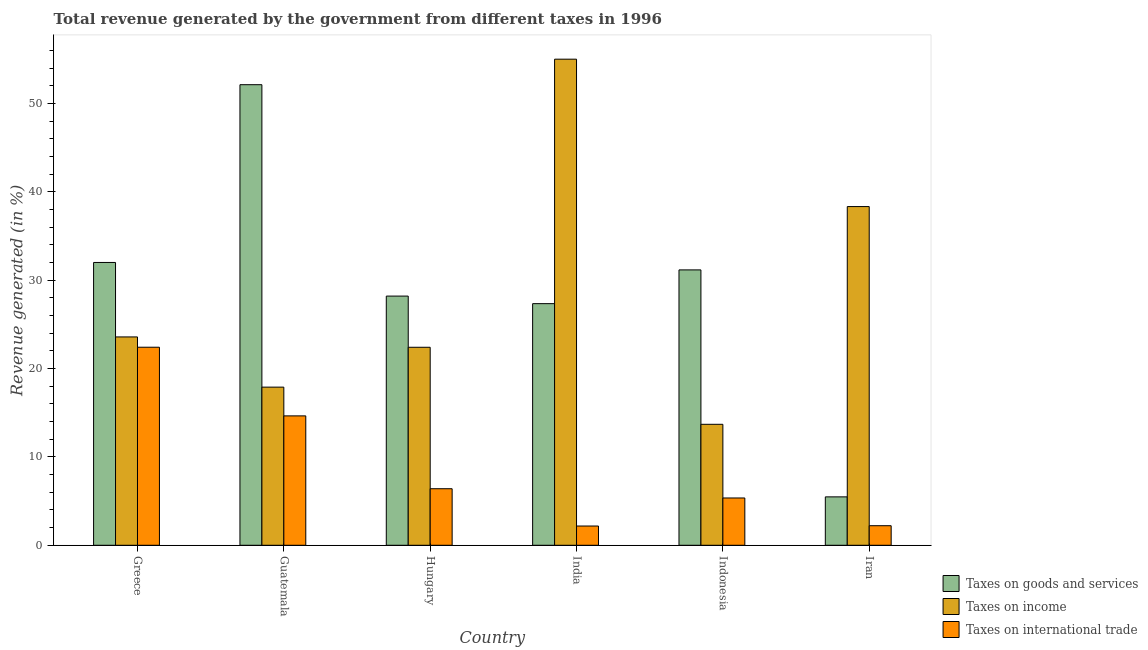How many groups of bars are there?
Your response must be concise. 6. What is the label of the 1st group of bars from the left?
Make the answer very short. Greece. In how many cases, is the number of bars for a given country not equal to the number of legend labels?
Offer a terse response. 0. What is the percentage of revenue generated by taxes on goods and services in Indonesia?
Keep it short and to the point. 31.16. Across all countries, what is the maximum percentage of revenue generated by taxes on income?
Offer a terse response. 55.01. Across all countries, what is the minimum percentage of revenue generated by taxes on goods and services?
Offer a very short reply. 5.48. In which country was the percentage of revenue generated by tax on international trade minimum?
Provide a short and direct response. India. What is the total percentage of revenue generated by taxes on goods and services in the graph?
Your answer should be compact. 176.3. What is the difference between the percentage of revenue generated by taxes on goods and services in Guatemala and that in Indonesia?
Keep it short and to the point. 20.96. What is the difference between the percentage of revenue generated by tax on international trade in Iran and the percentage of revenue generated by taxes on goods and services in India?
Make the answer very short. -25.13. What is the average percentage of revenue generated by tax on international trade per country?
Your answer should be very brief. 8.87. What is the difference between the percentage of revenue generated by tax on international trade and percentage of revenue generated by taxes on goods and services in Hungary?
Your response must be concise. -21.8. In how many countries, is the percentage of revenue generated by tax on international trade greater than 10 %?
Make the answer very short. 2. What is the ratio of the percentage of revenue generated by taxes on income in Guatemala to that in Hungary?
Provide a short and direct response. 0.8. Is the percentage of revenue generated by taxes on goods and services in Greece less than that in Iran?
Provide a succinct answer. No. What is the difference between the highest and the second highest percentage of revenue generated by taxes on goods and services?
Provide a short and direct response. 20.12. What is the difference between the highest and the lowest percentage of revenue generated by taxes on income?
Ensure brevity in your answer.  41.32. In how many countries, is the percentage of revenue generated by taxes on income greater than the average percentage of revenue generated by taxes on income taken over all countries?
Keep it short and to the point. 2. Is the sum of the percentage of revenue generated by taxes on goods and services in Guatemala and India greater than the maximum percentage of revenue generated by tax on international trade across all countries?
Keep it short and to the point. Yes. What does the 3rd bar from the left in Iran represents?
Keep it short and to the point. Taxes on international trade. What does the 2nd bar from the right in India represents?
Your answer should be very brief. Taxes on income. Is it the case that in every country, the sum of the percentage of revenue generated by taxes on goods and services and percentage of revenue generated by taxes on income is greater than the percentage of revenue generated by tax on international trade?
Give a very brief answer. Yes. How many bars are there?
Your response must be concise. 18. How many countries are there in the graph?
Offer a very short reply. 6. Are the values on the major ticks of Y-axis written in scientific E-notation?
Provide a succinct answer. No. Where does the legend appear in the graph?
Offer a terse response. Bottom right. What is the title of the graph?
Your response must be concise. Total revenue generated by the government from different taxes in 1996. Does "Unemployment benefits" appear as one of the legend labels in the graph?
Offer a very short reply. No. What is the label or title of the Y-axis?
Make the answer very short. Revenue generated (in %). What is the Revenue generated (in %) of Taxes on goods and services in Greece?
Provide a short and direct response. 32. What is the Revenue generated (in %) of Taxes on income in Greece?
Provide a succinct answer. 23.58. What is the Revenue generated (in %) in Taxes on international trade in Greece?
Make the answer very short. 22.41. What is the Revenue generated (in %) in Taxes on goods and services in Guatemala?
Make the answer very short. 52.12. What is the Revenue generated (in %) in Taxes on income in Guatemala?
Offer a terse response. 17.89. What is the Revenue generated (in %) in Taxes on international trade in Guatemala?
Ensure brevity in your answer.  14.64. What is the Revenue generated (in %) of Taxes on goods and services in Hungary?
Ensure brevity in your answer.  28.2. What is the Revenue generated (in %) in Taxes on income in Hungary?
Your answer should be very brief. 22.41. What is the Revenue generated (in %) of Taxes on international trade in Hungary?
Ensure brevity in your answer.  6.4. What is the Revenue generated (in %) in Taxes on goods and services in India?
Offer a very short reply. 27.34. What is the Revenue generated (in %) in Taxes on income in India?
Give a very brief answer. 55.01. What is the Revenue generated (in %) in Taxes on international trade in India?
Make the answer very short. 2.18. What is the Revenue generated (in %) of Taxes on goods and services in Indonesia?
Give a very brief answer. 31.16. What is the Revenue generated (in %) of Taxes on income in Indonesia?
Provide a short and direct response. 13.69. What is the Revenue generated (in %) in Taxes on international trade in Indonesia?
Ensure brevity in your answer.  5.35. What is the Revenue generated (in %) in Taxes on goods and services in Iran?
Provide a succinct answer. 5.48. What is the Revenue generated (in %) of Taxes on income in Iran?
Your response must be concise. 38.33. What is the Revenue generated (in %) in Taxes on international trade in Iran?
Offer a terse response. 2.21. Across all countries, what is the maximum Revenue generated (in %) of Taxes on goods and services?
Your answer should be very brief. 52.12. Across all countries, what is the maximum Revenue generated (in %) of Taxes on income?
Your response must be concise. 55.01. Across all countries, what is the maximum Revenue generated (in %) of Taxes on international trade?
Your answer should be compact. 22.41. Across all countries, what is the minimum Revenue generated (in %) of Taxes on goods and services?
Give a very brief answer. 5.48. Across all countries, what is the minimum Revenue generated (in %) of Taxes on income?
Keep it short and to the point. 13.69. Across all countries, what is the minimum Revenue generated (in %) in Taxes on international trade?
Offer a very short reply. 2.18. What is the total Revenue generated (in %) in Taxes on goods and services in the graph?
Your response must be concise. 176.3. What is the total Revenue generated (in %) of Taxes on income in the graph?
Give a very brief answer. 170.9. What is the total Revenue generated (in %) of Taxes on international trade in the graph?
Your response must be concise. 53.2. What is the difference between the Revenue generated (in %) in Taxes on goods and services in Greece and that in Guatemala?
Your response must be concise. -20.12. What is the difference between the Revenue generated (in %) in Taxes on income in Greece and that in Guatemala?
Make the answer very short. 5.68. What is the difference between the Revenue generated (in %) of Taxes on international trade in Greece and that in Guatemala?
Offer a very short reply. 7.77. What is the difference between the Revenue generated (in %) of Taxes on goods and services in Greece and that in Hungary?
Your answer should be compact. 3.81. What is the difference between the Revenue generated (in %) of Taxes on income in Greece and that in Hungary?
Keep it short and to the point. 1.17. What is the difference between the Revenue generated (in %) in Taxes on international trade in Greece and that in Hungary?
Provide a succinct answer. 16.01. What is the difference between the Revenue generated (in %) in Taxes on goods and services in Greece and that in India?
Provide a short and direct response. 4.66. What is the difference between the Revenue generated (in %) of Taxes on income in Greece and that in India?
Provide a succinct answer. -31.43. What is the difference between the Revenue generated (in %) in Taxes on international trade in Greece and that in India?
Provide a short and direct response. 20.23. What is the difference between the Revenue generated (in %) of Taxes on goods and services in Greece and that in Indonesia?
Your response must be concise. 0.84. What is the difference between the Revenue generated (in %) in Taxes on income in Greece and that in Indonesia?
Offer a terse response. 9.89. What is the difference between the Revenue generated (in %) in Taxes on international trade in Greece and that in Indonesia?
Offer a terse response. 17.06. What is the difference between the Revenue generated (in %) of Taxes on goods and services in Greece and that in Iran?
Keep it short and to the point. 26.53. What is the difference between the Revenue generated (in %) of Taxes on income in Greece and that in Iran?
Your response must be concise. -14.75. What is the difference between the Revenue generated (in %) in Taxes on international trade in Greece and that in Iran?
Make the answer very short. 20.2. What is the difference between the Revenue generated (in %) of Taxes on goods and services in Guatemala and that in Hungary?
Keep it short and to the point. 23.92. What is the difference between the Revenue generated (in %) in Taxes on income in Guatemala and that in Hungary?
Offer a terse response. -4.51. What is the difference between the Revenue generated (in %) of Taxes on international trade in Guatemala and that in Hungary?
Keep it short and to the point. 8.24. What is the difference between the Revenue generated (in %) of Taxes on goods and services in Guatemala and that in India?
Provide a short and direct response. 24.78. What is the difference between the Revenue generated (in %) of Taxes on income in Guatemala and that in India?
Offer a terse response. -37.11. What is the difference between the Revenue generated (in %) in Taxes on international trade in Guatemala and that in India?
Keep it short and to the point. 12.46. What is the difference between the Revenue generated (in %) in Taxes on goods and services in Guatemala and that in Indonesia?
Offer a very short reply. 20.96. What is the difference between the Revenue generated (in %) of Taxes on income in Guatemala and that in Indonesia?
Offer a very short reply. 4.21. What is the difference between the Revenue generated (in %) of Taxes on international trade in Guatemala and that in Indonesia?
Ensure brevity in your answer.  9.29. What is the difference between the Revenue generated (in %) of Taxes on goods and services in Guatemala and that in Iran?
Provide a succinct answer. 46.64. What is the difference between the Revenue generated (in %) of Taxes on income in Guatemala and that in Iran?
Provide a succinct answer. -20.43. What is the difference between the Revenue generated (in %) in Taxes on international trade in Guatemala and that in Iran?
Your response must be concise. 12.43. What is the difference between the Revenue generated (in %) of Taxes on goods and services in Hungary and that in India?
Provide a short and direct response. 0.86. What is the difference between the Revenue generated (in %) of Taxes on income in Hungary and that in India?
Give a very brief answer. -32.6. What is the difference between the Revenue generated (in %) in Taxes on international trade in Hungary and that in India?
Offer a terse response. 4.22. What is the difference between the Revenue generated (in %) of Taxes on goods and services in Hungary and that in Indonesia?
Your answer should be compact. -2.96. What is the difference between the Revenue generated (in %) in Taxes on income in Hungary and that in Indonesia?
Provide a succinct answer. 8.72. What is the difference between the Revenue generated (in %) in Taxes on international trade in Hungary and that in Indonesia?
Give a very brief answer. 1.05. What is the difference between the Revenue generated (in %) of Taxes on goods and services in Hungary and that in Iran?
Ensure brevity in your answer.  22.72. What is the difference between the Revenue generated (in %) in Taxes on income in Hungary and that in Iran?
Ensure brevity in your answer.  -15.92. What is the difference between the Revenue generated (in %) of Taxes on international trade in Hungary and that in Iran?
Your response must be concise. 4.18. What is the difference between the Revenue generated (in %) of Taxes on goods and services in India and that in Indonesia?
Offer a terse response. -3.82. What is the difference between the Revenue generated (in %) in Taxes on income in India and that in Indonesia?
Make the answer very short. 41.32. What is the difference between the Revenue generated (in %) of Taxes on international trade in India and that in Indonesia?
Give a very brief answer. -3.17. What is the difference between the Revenue generated (in %) of Taxes on goods and services in India and that in Iran?
Your response must be concise. 21.86. What is the difference between the Revenue generated (in %) in Taxes on income in India and that in Iran?
Provide a succinct answer. 16.68. What is the difference between the Revenue generated (in %) of Taxes on international trade in India and that in Iran?
Make the answer very short. -0.04. What is the difference between the Revenue generated (in %) in Taxes on goods and services in Indonesia and that in Iran?
Offer a terse response. 25.68. What is the difference between the Revenue generated (in %) in Taxes on income in Indonesia and that in Iran?
Your answer should be very brief. -24.64. What is the difference between the Revenue generated (in %) of Taxes on international trade in Indonesia and that in Iran?
Your answer should be compact. 3.14. What is the difference between the Revenue generated (in %) of Taxes on goods and services in Greece and the Revenue generated (in %) of Taxes on income in Guatemala?
Make the answer very short. 14.11. What is the difference between the Revenue generated (in %) in Taxes on goods and services in Greece and the Revenue generated (in %) in Taxes on international trade in Guatemala?
Provide a short and direct response. 17.36. What is the difference between the Revenue generated (in %) in Taxes on income in Greece and the Revenue generated (in %) in Taxes on international trade in Guatemala?
Your response must be concise. 8.93. What is the difference between the Revenue generated (in %) in Taxes on goods and services in Greece and the Revenue generated (in %) in Taxes on income in Hungary?
Offer a terse response. 9.6. What is the difference between the Revenue generated (in %) in Taxes on goods and services in Greece and the Revenue generated (in %) in Taxes on international trade in Hungary?
Your answer should be compact. 25.6. What is the difference between the Revenue generated (in %) in Taxes on income in Greece and the Revenue generated (in %) in Taxes on international trade in Hungary?
Offer a very short reply. 17.18. What is the difference between the Revenue generated (in %) of Taxes on goods and services in Greece and the Revenue generated (in %) of Taxes on income in India?
Ensure brevity in your answer.  -23. What is the difference between the Revenue generated (in %) in Taxes on goods and services in Greece and the Revenue generated (in %) in Taxes on international trade in India?
Your answer should be very brief. 29.82. What is the difference between the Revenue generated (in %) in Taxes on income in Greece and the Revenue generated (in %) in Taxes on international trade in India?
Provide a succinct answer. 21.4. What is the difference between the Revenue generated (in %) in Taxes on goods and services in Greece and the Revenue generated (in %) in Taxes on income in Indonesia?
Your answer should be very brief. 18.32. What is the difference between the Revenue generated (in %) of Taxes on goods and services in Greece and the Revenue generated (in %) of Taxes on international trade in Indonesia?
Give a very brief answer. 26.65. What is the difference between the Revenue generated (in %) in Taxes on income in Greece and the Revenue generated (in %) in Taxes on international trade in Indonesia?
Offer a very short reply. 18.22. What is the difference between the Revenue generated (in %) in Taxes on goods and services in Greece and the Revenue generated (in %) in Taxes on income in Iran?
Provide a succinct answer. -6.32. What is the difference between the Revenue generated (in %) of Taxes on goods and services in Greece and the Revenue generated (in %) of Taxes on international trade in Iran?
Offer a very short reply. 29.79. What is the difference between the Revenue generated (in %) in Taxes on income in Greece and the Revenue generated (in %) in Taxes on international trade in Iran?
Provide a short and direct response. 21.36. What is the difference between the Revenue generated (in %) in Taxes on goods and services in Guatemala and the Revenue generated (in %) in Taxes on income in Hungary?
Make the answer very short. 29.71. What is the difference between the Revenue generated (in %) in Taxes on goods and services in Guatemala and the Revenue generated (in %) in Taxes on international trade in Hungary?
Your response must be concise. 45.72. What is the difference between the Revenue generated (in %) in Taxes on income in Guatemala and the Revenue generated (in %) in Taxes on international trade in Hungary?
Your response must be concise. 11.5. What is the difference between the Revenue generated (in %) of Taxes on goods and services in Guatemala and the Revenue generated (in %) of Taxes on income in India?
Provide a short and direct response. -2.89. What is the difference between the Revenue generated (in %) in Taxes on goods and services in Guatemala and the Revenue generated (in %) in Taxes on international trade in India?
Give a very brief answer. 49.94. What is the difference between the Revenue generated (in %) of Taxes on income in Guatemala and the Revenue generated (in %) of Taxes on international trade in India?
Provide a succinct answer. 15.72. What is the difference between the Revenue generated (in %) of Taxes on goods and services in Guatemala and the Revenue generated (in %) of Taxes on income in Indonesia?
Keep it short and to the point. 38.43. What is the difference between the Revenue generated (in %) of Taxes on goods and services in Guatemala and the Revenue generated (in %) of Taxes on international trade in Indonesia?
Give a very brief answer. 46.77. What is the difference between the Revenue generated (in %) of Taxes on income in Guatemala and the Revenue generated (in %) of Taxes on international trade in Indonesia?
Your response must be concise. 12.54. What is the difference between the Revenue generated (in %) in Taxes on goods and services in Guatemala and the Revenue generated (in %) in Taxes on income in Iran?
Your response must be concise. 13.79. What is the difference between the Revenue generated (in %) of Taxes on goods and services in Guatemala and the Revenue generated (in %) of Taxes on international trade in Iran?
Your response must be concise. 49.9. What is the difference between the Revenue generated (in %) of Taxes on income in Guatemala and the Revenue generated (in %) of Taxes on international trade in Iran?
Your answer should be very brief. 15.68. What is the difference between the Revenue generated (in %) in Taxes on goods and services in Hungary and the Revenue generated (in %) in Taxes on income in India?
Your answer should be very brief. -26.81. What is the difference between the Revenue generated (in %) in Taxes on goods and services in Hungary and the Revenue generated (in %) in Taxes on international trade in India?
Provide a short and direct response. 26.02. What is the difference between the Revenue generated (in %) in Taxes on income in Hungary and the Revenue generated (in %) in Taxes on international trade in India?
Your answer should be very brief. 20.23. What is the difference between the Revenue generated (in %) in Taxes on goods and services in Hungary and the Revenue generated (in %) in Taxes on income in Indonesia?
Ensure brevity in your answer.  14.51. What is the difference between the Revenue generated (in %) in Taxes on goods and services in Hungary and the Revenue generated (in %) in Taxes on international trade in Indonesia?
Your answer should be very brief. 22.84. What is the difference between the Revenue generated (in %) of Taxes on income in Hungary and the Revenue generated (in %) of Taxes on international trade in Indonesia?
Keep it short and to the point. 17.05. What is the difference between the Revenue generated (in %) in Taxes on goods and services in Hungary and the Revenue generated (in %) in Taxes on income in Iran?
Ensure brevity in your answer.  -10.13. What is the difference between the Revenue generated (in %) in Taxes on goods and services in Hungary and the Revenue generated (in %) in Taxes on international trade in Iran?
Your response must be concise. 25.98. What is the difference between the Revenue generated (in %) of Taxes on income in Hungary and the Revenue generated (in %) of Taxes on international trade in Iran?
Keep it short and to the point. 20.19. What is the difference between the Revenue generated (in %) of Taxes on goods and services in India and the Revenue generated (in %) of Taxes on income in Indonesia?
Ensure brevity in your answer.  13.65. What is the difference between the Revenue generated (in %) of Taxes on goods and services in India and the Revenue generated (in %) of Taxes on international trade in Indonesia?
Make the answer very short. 21.99. What is the difference between the Revenue generated (in %) in Taxes on income in India and the Revenue generated (in %) in Taxes on international trade in Indonesia?
Make the answer very short. 49.65. What is the difference between the Revenue generated (in %) of Taxes on goods and services in India and the Revenue generated (in %) of Taxes on income in Iran?
Your answer should be compact. -10.99. What is the difference between the Revenue generated (in %) in Taxes on goods and services in India and the Revenue generated (in %) in Taxes on international trade in Iran?
Offer a very short reply. 25.13. What is the difference between the Revenue generated (in %) in Taxes on income in India and the Revenue generated (in %) in Taxes on international trade in Iran?
Keep it short and to the point. 52.79. What is the difference between the Revenue generated (in %) in Taxes on goods and services in Indonesia and the Revenue generated (in %) in Taxes on income in Iran?
Offer a terse response. -7.17. What is the difference between the Revenue generated (in %) in Taxes on goods and services in Indonesia and the Revenue generated (in %) in Taxes on international trade in Iran?
Offer a terse response. 28.95. What is the difference between the Revenue generated (in %) of Taxes on income in Indonesia and the Revenue generated (in %) of Taxes on international trade in Iran?
Give a very brief answer. 11.47. What is the average Revenue generated (in %) in Taxes on goods and services per country?
Keep it short and to the point. 29.38. What is the average Revenue generated (in %) in Taxes on income per country?
Offer a very short reply. 28.48. What is the average Revenue generated (in %) of Taxes on international trade per country?
Offer a very short reply. 8.87. What is the difference between the Revenue generated (in %) in Taxes on goods and services and Revenue generated (in %) in Taxes on income in Greece?
Keep it short and to the point. 8.43. What is the difference between the Revenue generated (in %) in Taxes on goods and services and Revenue generated (in %) in Taxes on international trade in Greece?
Give a very brief answer. 9.59. What is the difference between the Revenue generated (in %) of Taxes on income and Revenue generated (in %) of Taxes on international trade in Greece?
Give a very brief answer. 1.17. What is the difference between the Revenue generated (in %) of Taxes on goods and services and Revenue generated (in %) of Taxes on income in Guatemala?
Offer a terse response. 34.22. What is the difference between the Revenue generated (in %) of Taxes on goods and services and Revenue generated (in %) of Taxes on international trade in Guatemala?
Give a very brief answer. 37.48. What is the difference between the Revenue generated (in %) of Taxes on income and Revenue generated (in %) of Taxes on international trade in Guatemala?
Ensure brevity in your answer.  3.25. What is the difference between the Revenue generated (in %) of Taxes on goods and services and Revenue generated (in %) of Taxes on income in Hungary?
Provide a succinct answer. 5.79. What is the difference between the Revenue generated (in %) in Taxes on goods and services and Revenue generated (in %) in Taxes on international trade in Hungary?
Keep it short and to the point. 21.8. What is the difference between the Revenue generated (in %) in Taxes on income and Revenue generated (in %) in Taxes on international trade in Hungary?
Offer a terse response. 16.01. What is the difference between the Revenue generated (in %) in Taxes on goods and services and Revenue generated (in %) in Taxes on income in India?
Your answer should be compact. -27.66. What is the difference between the Revenue generated (in %) in Taxes on goods and services and Revenue generated (in %) in Taxes on international trade in India?
Your answer should be compact. 25.16. What is the difference between the Revenue generated (in %) of Taxes on income and Revenue generated (in %) of Taxes on international trade in India?
Make the answer very short. 52.83. What is the difference between the Revenue generated (in %) of Taxes on goods and services and Revenue generated (in %) of Taxes on income in Indonesia?
Make the answer very short. 17.47. What is the difference between the Revenue generated (in %) in Taxes on goods and services and Revenue generated (in %) in Taxes on international trade in Indonesia?
Keep it short and to the point. 25.81. What is the difference between the Revenue generated (in %) in Taxes on income and Revenue generated (in %) in Taxes on international trade in Indonesia?
Give a very brief answer. 8.34. What is the difference between the Revenue generated (in %) of Taxes on goods and services and Revenue generated (in %) of Taxes on income in Iran?
Provide a succinct answer. -32.85. What is the difference between the Revenue generated (in %) in Taxes on goods and services and Revenue generated (in %) in Taxes on international trade in Iran?
Provide a succinct answer. 3.26. What is the difference between the Revenue generated (in %) of Taxes on income and Revenue generated (in %) of Taxes on international trade in Iran?
Make the answer very short. 36.11. What is the ratio of the Revenue generated (in %) in Taxes on goods and services in Greece to that in Guatemala?
Make the answer very short. 0.61. What is the ratio of the Revenue generated (in %) of Taxes on income in Greece to that in Guatemala?
Keep it short and to the point. 1.32. What is the ratio of the Revenue generated (in %) in Taxes on international trade in Greece to that in Guatemala?
Give a very brief answer. 1.53. What is the ratio of the Revenue generated (in %) in Taxes on goods and services in Greece to that in Hungary?
Give a very brief answer. 1.14. What is the ratio of the Revenue generated (in %) in Taxes on income in Greece to that in Hungary?
Your answer should be very brief. 1.05. What is the ratio of the Revenue generated (in %) of Taxes on international trade in Greece to that in Hungary?
Offer a terse response. 3.5. What is the ratio of the Revenue generated (in %) of Taxes on goods and services in Greece to that in India?
Provide a short and direct response. 1.17. What is the ratio of the Revenue generated (in %) of Taxes on income in Greece to that in India?
Your answer should be compact. 0.43. What is the ratio of the Revenue generated (in %) of Taxes on international trade in Greece to that in India?
Your answer should be very brief. 10.29. What is the ratio of the Revenue generated (in %) of Taxes on goods and services in Greece to that in Indonesia?
Offer a terse response. 1.03. What is the ratio of the Revenue generated (in %) of Taxes on income in Greece to that in Indonesia?
Keep it short and to the point. 1.72. What is the ratio of the Revenue generated (in %) of Taxes on international trade in Greece to that in Indonesia?
Provide a short and direct response. 4.19. What is the ratio of the Revenue generated (in %) in Taxes on goods and services in Greece to that in Iran?
Keep it short and to the point. 5.84. What is the ratio of the Revenue generated (in %) in Taxes on income in Greece to that in Iran?
Offer a terse response. 0.62. What is the ratio of the Revenue generated (in %) of Taxes on international trade in Greece to that in Iran?
Offer a terse response. 10.12. What is the ratio of the Revenue generated (in %) in Taxes on goods and services in Guatemala to that in Hungary?
Provide a short and direct response. 1.85. What is the ratio of the Revenue generated (in %) in Taxes on income in Guatemala to that in Hungary?
Your answer should be very brief. 0.8. What is the ratio of the Revenue generated (in %) of Taxes on international trade in Guatemala to that in Hungary?
Offer a terse response. 2.29. What is the ratio of the Revenue generated (in %) of Taxes on goods and services in Guatemala to that in India?
Provide a succinct answer. 1.91. What is the ratio of the Revenue generated (in %) of Taxes on income in Guatemala to that in India?
Offer a terse response. 0.33. What is the ratio of the Revenue generated (in %) of Taxes on international trade in Guatemala to that in India?
Offer a terse response. 6.72. What is the ratio of the Revenue generated (in %) of Taxes on goods and services in Guatemala to that in Indonesia?
Your answer should be very brief. 1.67. What is the ratio of the Revenue generated (in %) in Taxes on income in Guatemala to that in Indonesia?
Provide a succinct answer. 1.31. What is the ratio of the Revenue generated (in %) in Taxes on international trade in Guatemala to that in Indonesia?
Your response must be concise. 2.74. What is the ratio of the Revenue generated (in %) of Taxes on goods and services in Guatemala to that in Iran?
Make the answer very short. 9.51. What is the ratio of the Revenue generated (in %) in Taxes on income in Guatemala to that in Iran?
Your response must be concise. 0.47. What is the ratio of the Revenue generated (in %) in Taxes on international trade in Guatemala to that in Iran?
Give a very brief answer. 6.61. What is the ratio of the Revenue generated (in %) of Taxes on goods and services in Hungary to that in India?
Provide a succinct answer. 1.03. What is the ratio of the Revenue generated (in %) in Taxes on income in Hungary to that in India?
Your answer should be compact. 0.41. What is the ratio of the Revenue generated (in %) in Taxes on international trade in Hungary to that in India?
Your answer should be compact. 2.94. What is the ratio of the Revenue generated (in %) of Taxes on goods and services in Hungary to that in Indonesia?
Your response must be concise. 0.9. What is the ratio of the Revenue generated (in %) in Taxes on income in Hungary to that in Indonesia?
Provide a short and direct response. 1.64. What is the ratio of the Revenue generated (in %) of Taxes on international trade in Hungary to that in Indonesia?
Provide a succinct answer. 1.2. What is the ratio of the Revenue generated (in %) of Taxes on goods and services in Hungary to that in Iran?
Your answer should be very brief. 5.15. What is the ratio of the Revenue generated (in %) of Taxes on income in Hungary to that in Iran?
Provide a succinct answer. 0.58. What is the ratio of the Revenue generated (in %) in Taxes on international trade in Hungary to that in Iran?
Provide a succinct answer. 2.89. What is the ratio of the Revenue generated (in %) in Taxes on goods and services in India to that in Indonesia?
Your answer should be very brief. 0.88. What is the ratio of the Revenue generated (in %) of Taxes on income in India to that in Indonesia?
Make the answer very short. 4.02. What is the ratio of the Revenue generated (in %) in Taxes on international trade in India to that in Indonesia?
Provide a short and direct response. 0.41. What is the ratio of the Revenue generated (in %) of Taxes on goods and services in India to that in Iran?
Provide a short and direct response. 4.99. What is the ratio of the Revenue generated (in %) in Taxes on income in India to that in Iran?
Offer a very short reply. 1.44. What is the ratio of the Revenue generated (in %) of Taxes on international trade in India to that in Iran?
Give a very brief answer. 0.98. What is the ratio of the Revenue generated (in %) of Taxes on goods and services in Indonesia to that in Iran?
Provide a short and direct response. 5.69. What is the ratio of the Revenue generated (in %) of Taxes on income in Indonesia to that in Iran?
Your answer should be compact. 0.36. What is the ratio of the Revenue generated (in %) of Taxes on international trade in Indonesia to that in Iran?
Offer a terse response. 2.42. What is the difference between the highest and the second highest Revenue generated (in %) of Taxes on goods and services?
Your answer should be compact. 20.12. What is the difference between the highest and the second highest Revenue generated (in %) of Taxes on income?
Offer a terse response. 16.68. What is the difference between the highest and the second highest Revenue generated (in %) in Taxes on international trade?
Your answer should be compact. 7.77. What is the difference between the highest and the lowest Revenue generated (in %) in Taxes on goods and services?
Make the answer very short. 46.64. What is the difference between the highest and the lowest Revenue generated (in %) of Taxes on income?
Make the answer very short. 41.32. What is the difference between the highest and the lowest Revenue generated (in %) in Taxes on international trade?
Provide a succinct answer. 20.23. 